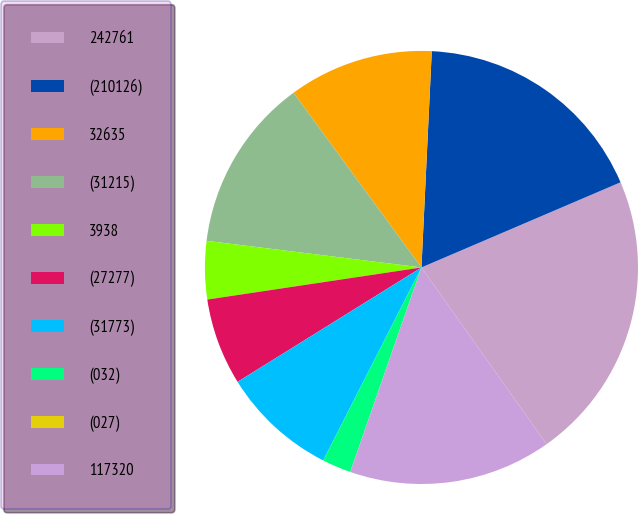<chart> <loc_0><loc_0><loc_500><loc_500><pie_chart><fcel>242761<fcel>(210126)<fcel>32635<fcel>(31215)<fcel>3938<fcel>(27277)<fcel>(31773)<fcel>(032)<fcel>(027)<fcel>117320<nl><fcel>21.63%<fcel>17.81%<fcel>10.82%<fcel>12.98%<fcel>4.33%<fcel>6.49%<fcel>8.65%<fcel>2.16%<fcel>0.0%<fcel>15.14%<nl></chart> 